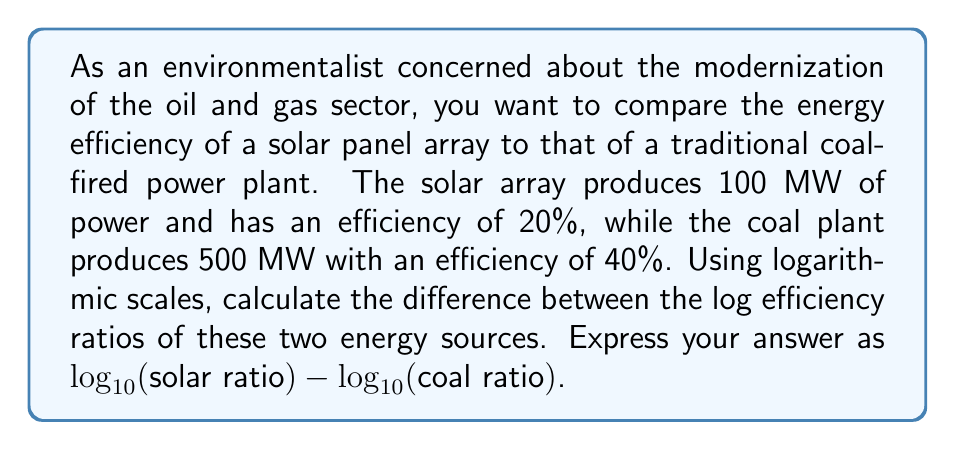Could you help me with this problem? To solve this problem, we'll follow these steps:

1) First, let's define the efficiency ratio for each energy source:
   Efficiency ratio = Power output / Efficiency

2) For the solar array:
   Solar ratio = $100 \text{ MW} / 0.20 = 500 \text{ MW}$

3) For the coal plant:
   Coal ratio = $500 \text{ MW} / 0.40 = 1250 \text{ MW}$

4) Now, we need to calculate $\log_{10}$ of each ratio:

   $\log_{10}(\text{solar ratio}) = \log_{10}(500) = 2.6989700043$
   
   $\log_{10}(\text{coal ratio}) = \log_{10}(1250) = 3.0969100130$

5) Finally, we subtract the coal log from the solar log:

   $\log_{10}(\text{solar ratio}) - \log_{10}(\text{coal ratio}) = 2.6989700043 - 3.0969100130$

   $= -0.3979400087$

This negative result indicates that the coal plant has a higher efficiency ratio when compared on a logarithmic scale.
Answer: $-0.3979400087$ 